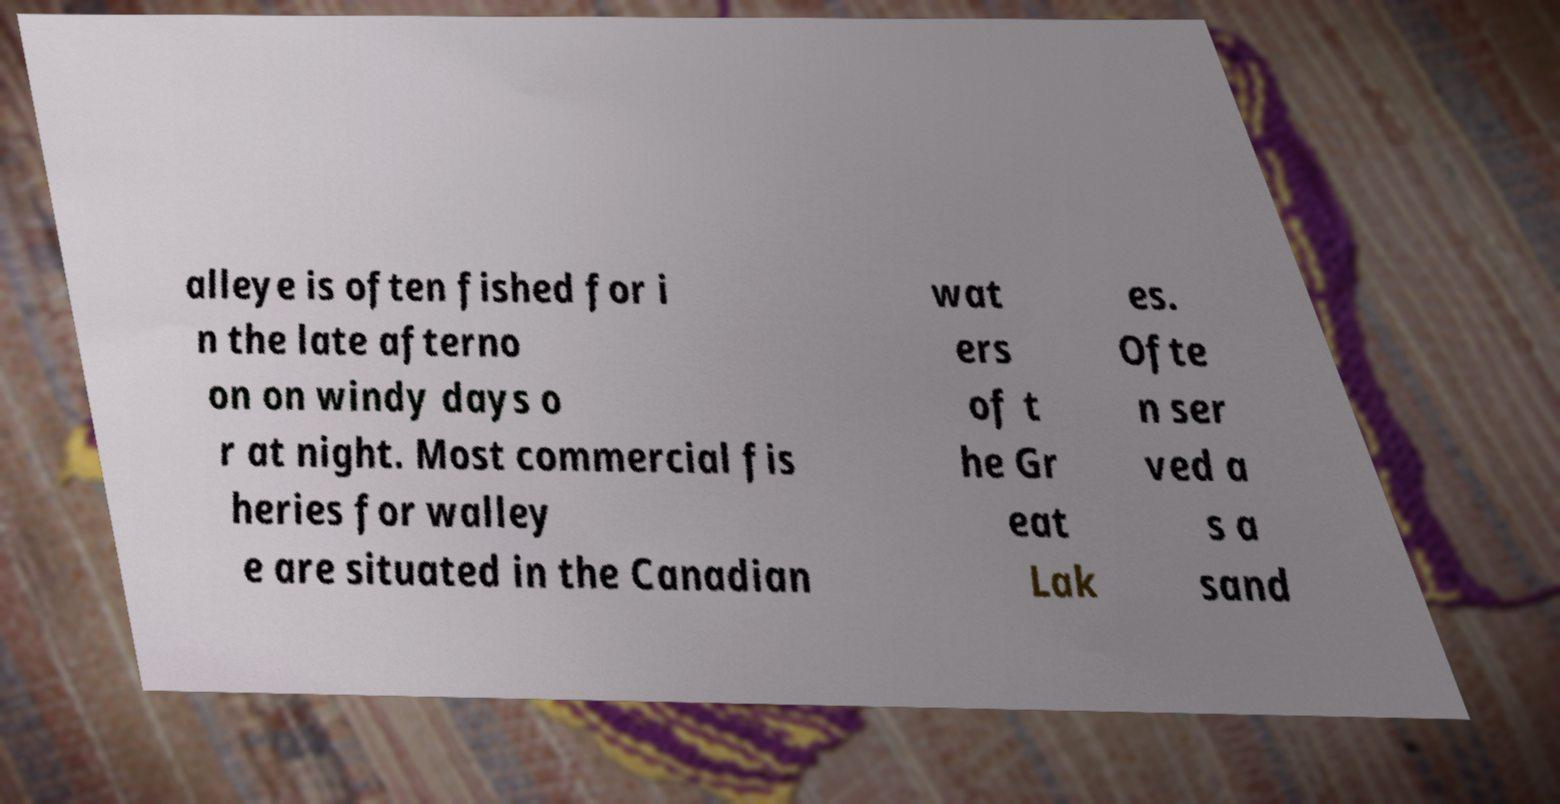For documentation purposes, I need the text within this image transcribed. Could you provide that? alleye is often fished for i n the late afterno on on windy days o r at night. Most commercial fis heries for walley e are situated in the Canadian wat ers of t he Gr eat Lak es. Ofte n ser ved a s a sand 